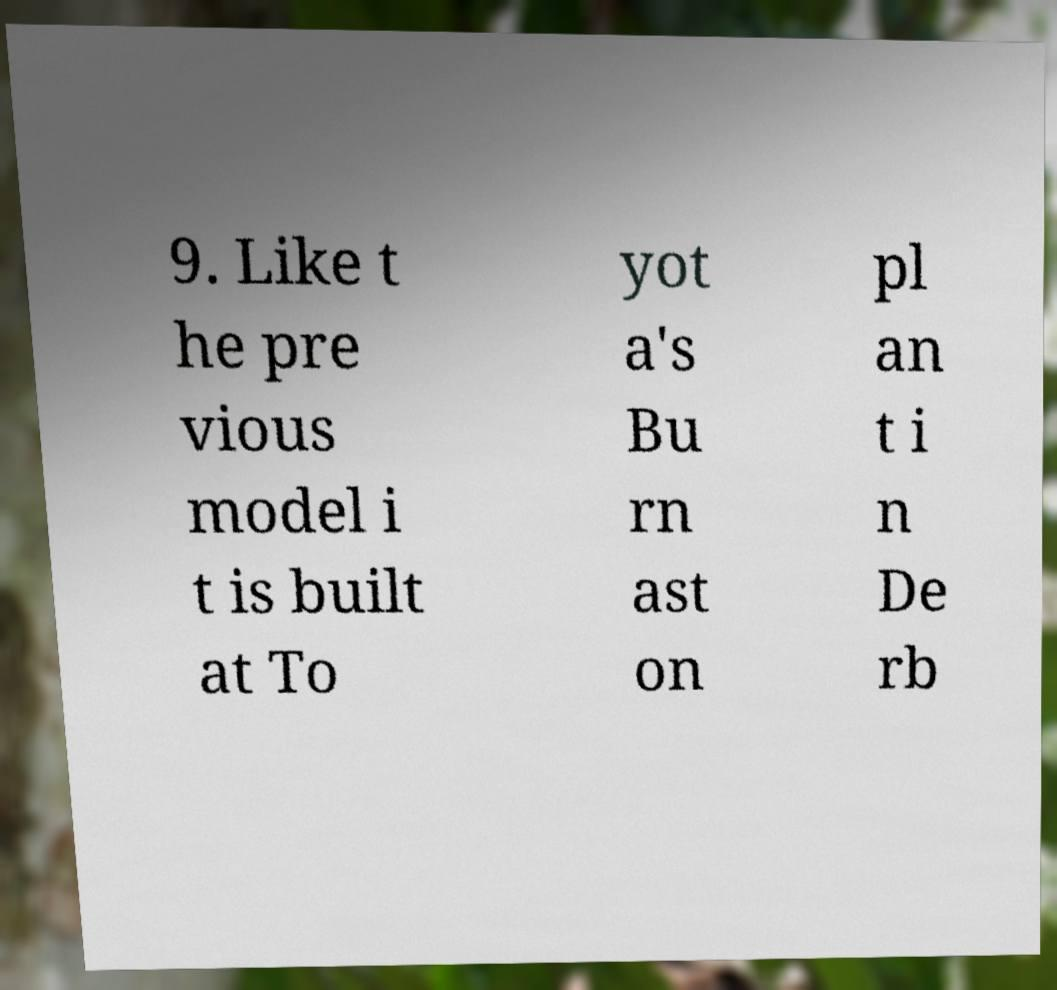Can you read and provide the text displayed in the image?This photo seems to have some interesting text. Can you extract and type it out for me? 9. Like t he pre vious model i t is built at To yot a's Bu rn ast on pl an t i n De rb 